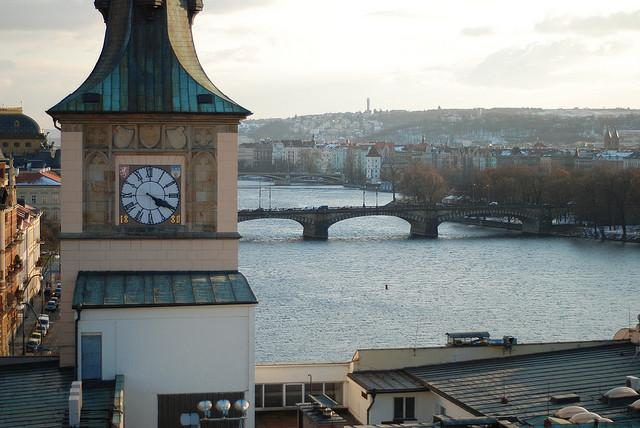What do the numbers on either side of the clock represent?

Choices:
A) nothing
B) name
C) date
D) time date 